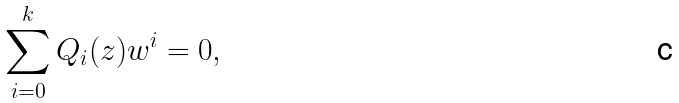<formula> <loc_0><loc_0><loc_500><loc_500>\sum _ { i = 0 } ^ { k } Q _ { i } ( z ) w ^ { i } = 0 ,</formula> 